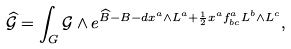Convert formula to latex. <formula><loc_0><loc_0><loc_500><loc_500>\widehat { \mathcal { G } } = \int _ { G } \mathcal { G } \wedge e ^ { \widehat { B } - B - d x ^ { a } \wedge L ^ { a } + \frac { 1 } { 2 } x ^ { a } f _ { b c } ^ { a } L ^ { b } \wedge L ^ { c } } ,</formula> 